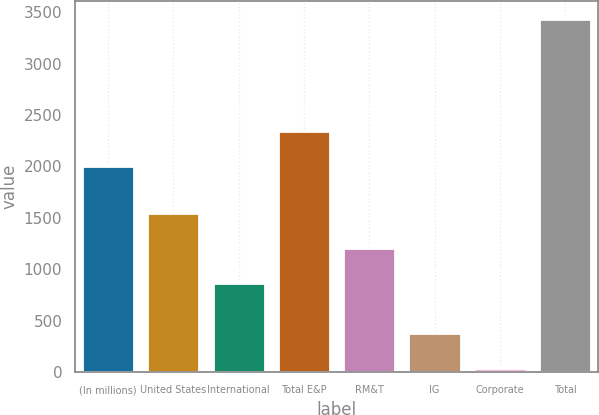<chart> <loc_0><loc_0><loc_500><loc_500><bar_chart><fcel>(In millions)<fcel>United States<fcel>International<fcel>Total E&P<fcel>RM&T<fcel>IG<fcel>Corporate<fcel>Total<nl><fcel>2006<fcel>1545.4<fcel>867<fcel>2345.2<fcel>1206.2<fcel>380.2<fcel>41<fcel>3433<nl></chart> 